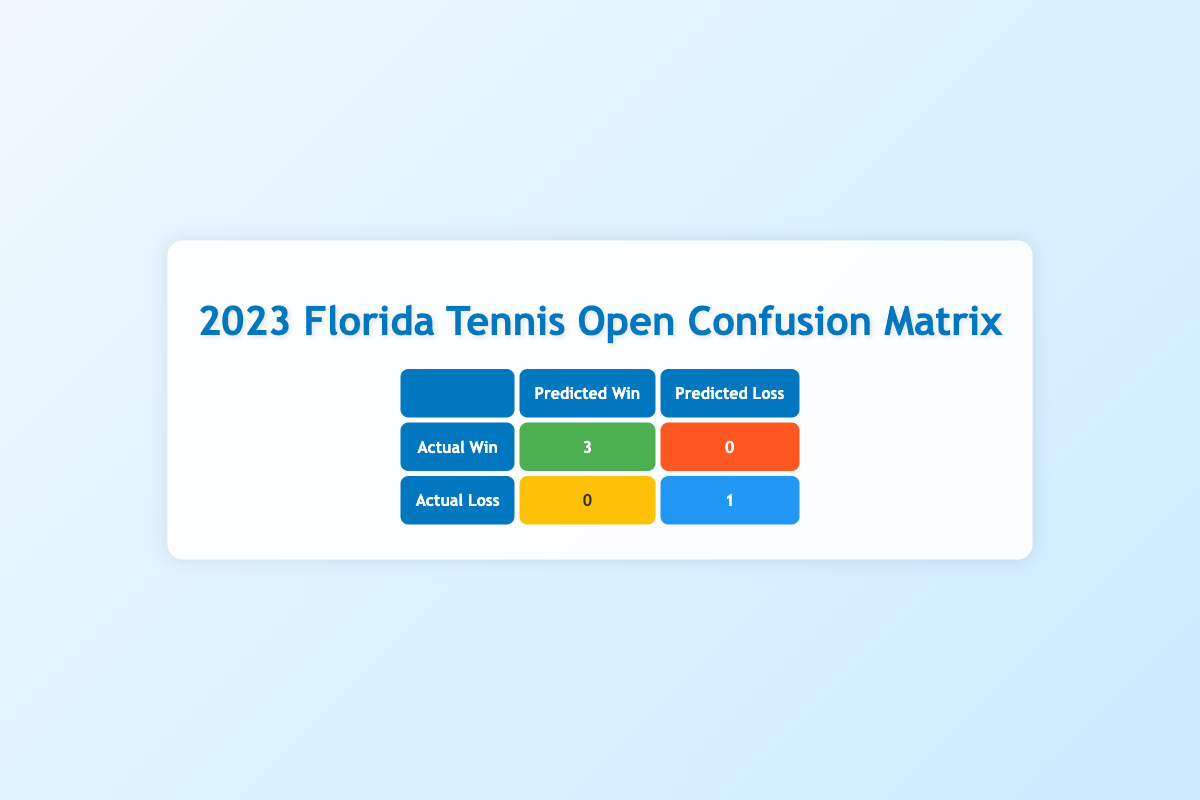What is the total number of matches won by the players? In the table, "Actual Win" indicates matches that players won. The total for "Actual Win" is 3, which reflects the matches won by players.
Answer: 3 How many matches did Emma Navarro play in the tournament? Emma Navarro is listed as player1 in one match where she won, which means she played one match in the tournament.
Answer: 1 Did any player win after having a higher number of double faults than their opponent? In the table, Tommy Paul has 4 double faults while his opponent Jack Sock has 2 double faults but Tommy Paul won the match. Therefore, yes, there was at least one instance where a player won despite having more double faults.
Answer: Yes What is the average first serve percentage of the players who won their matches? The first serve percentages for winning players are Emma Navarro (68), Peyton Stearns (75), and Tommy Paul (70). Adding these gives 213, and dividing by 3 results in an average of 71.
Answer: 71 What was the predicted loss for players who actually won their matches? The table shows that all players who won their matches (3 wins) are correctly predicted as wins (no false negatives), thus the predicted loss for those players is 0.
Answer: 0 How many players lost having saved fewer break points than their opponent? The only player listed as a loser is Ben Shelton, who saved 3 break points while Frances Tiafoe saved 5, confirming he saved fewer. Therefore, yes, one player lost with fewer break points saved.
Answer: Yes What is the relationship between the match duration and the actual winners? The durations of matches won by players were 105, 90, and 95 minutes. The durations do not show a direct correlation with winning but the average duration of winning matches is calculated as (105 + 90 + 95) / 3 = 96.67 minutes.
Answer: 96.67 minutes How many players scored more aces than their opponent in matches they lost? In the match between Ben Shelton and Frances Tiafoe, Ben Shelton scored 6 aces while Frances Tiafoe scored 8 and Ben lost. Therefore, 0 players scored more aces than their opponents in matches they lost.
Answer: 0 What is the total number of false positives measured in the table? The table displays 0 false positives for players as all predictions regarding losses were accurate except for one (a true negative). Thus, the total is 0.
Answer: 0 